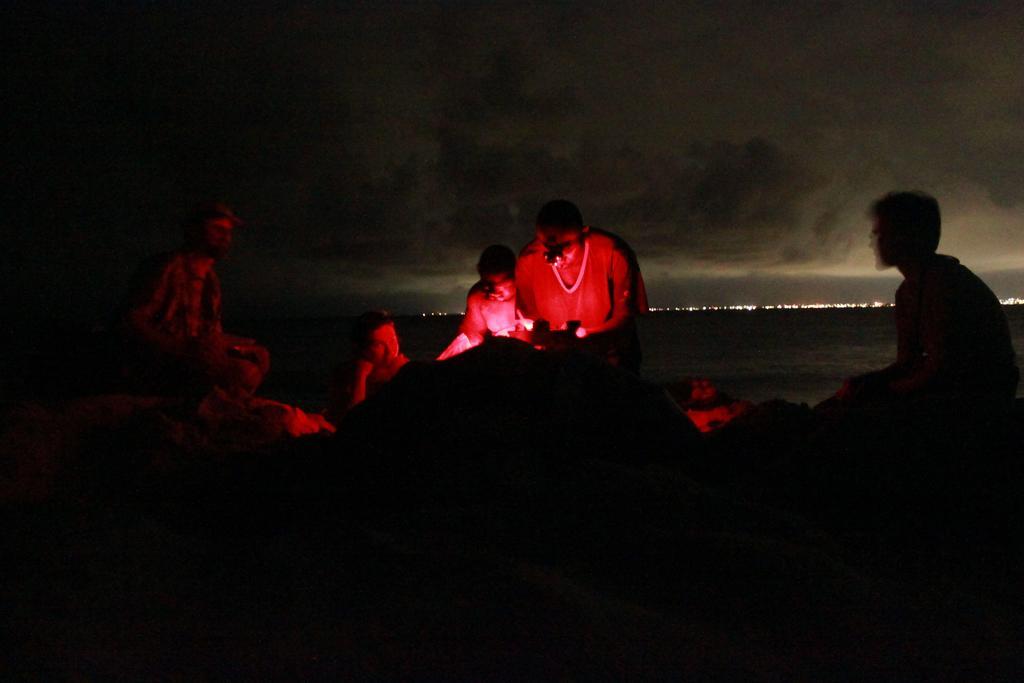In one or two sentences, can you explain what this image depicts? This picture is dark, in this picture there are people and we can see water. In the background of the image we can see lights and sky. 